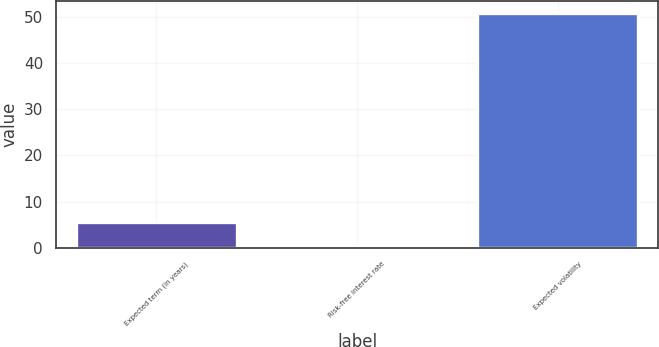Convert chart to OTSL. <chart><loc_0><loc_0><loc_500><loc_500><bar_chart><fcel>Expected term (in years)<fcel>Risk-free interest rate<fcel>Expected volatility<nl><fcel>5.62<fcel>0.6<fcel>50.8<nl></chart> 